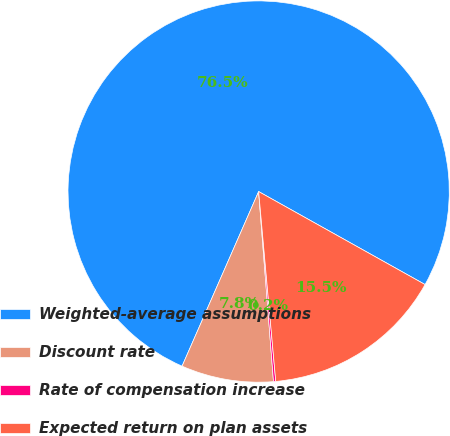Convert chart to OTSL. <chart><loc_0><loc_0><loc_500><loc_500><pie_chart><fcel>Weighted-average assumptions<fcel>Discount rate<fcel>Rate of compensation increase<fcel>Expected return on plan assets<nl><fcel>76.53%<fcel>7.82%<fcel>0.19%<fcel>15.46%<nl></chart> 